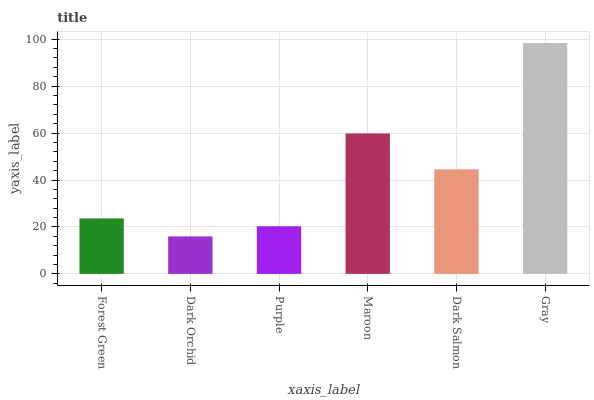Is Dark Orchid the minimum?
Answer yes or no. Yes. Is Gray the maximum?
Answer yes or no. Yes. Is Purple the minimum?
Answer yes or no. No. Is Purple the maximum?
Answer yes or no. No. Is Purple greater than Dark Orchid?
Answer yes or no. Yes. Is Dark Orchid less than Purple?
Answer yes or no. Yes. Is Dark Orchid greater than Purple?
Answer yes or no. No. Is Purple less than Dark Orchid?
Answer yes or no. No. Is Dark Salmon the high median?
Answer yes or no. Yes. Is Forest Green the low median?
Answer yes or no. Yes. Is Forest Green the high median?
Answer yes or no. No. Is Dark Orchid the low median?
Answer yes or no. No. 